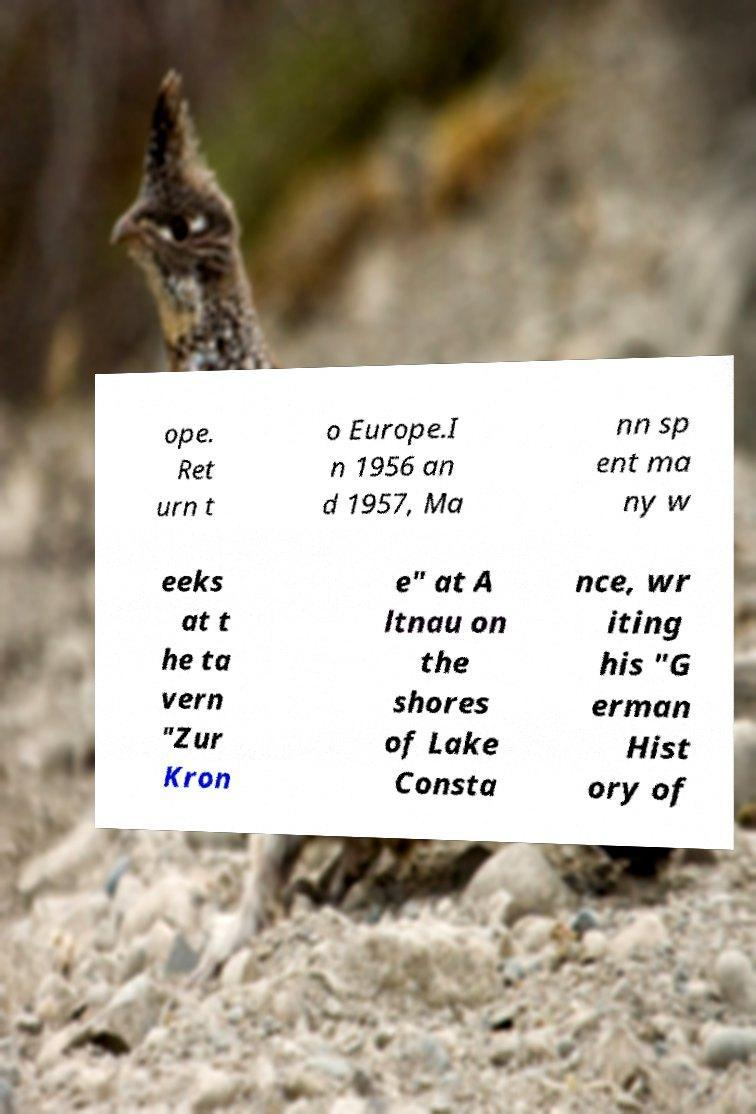Could you extract and type out the text from this image? ope. Ret urn t o Europe.I n 1956 an d 1957, Ma nn sp ent ma ny w eeks at t he ta vern "Zur Kron e" at A ltnau on the shores of Lake Consta nce, wr iting his "G erman Hist ory of 